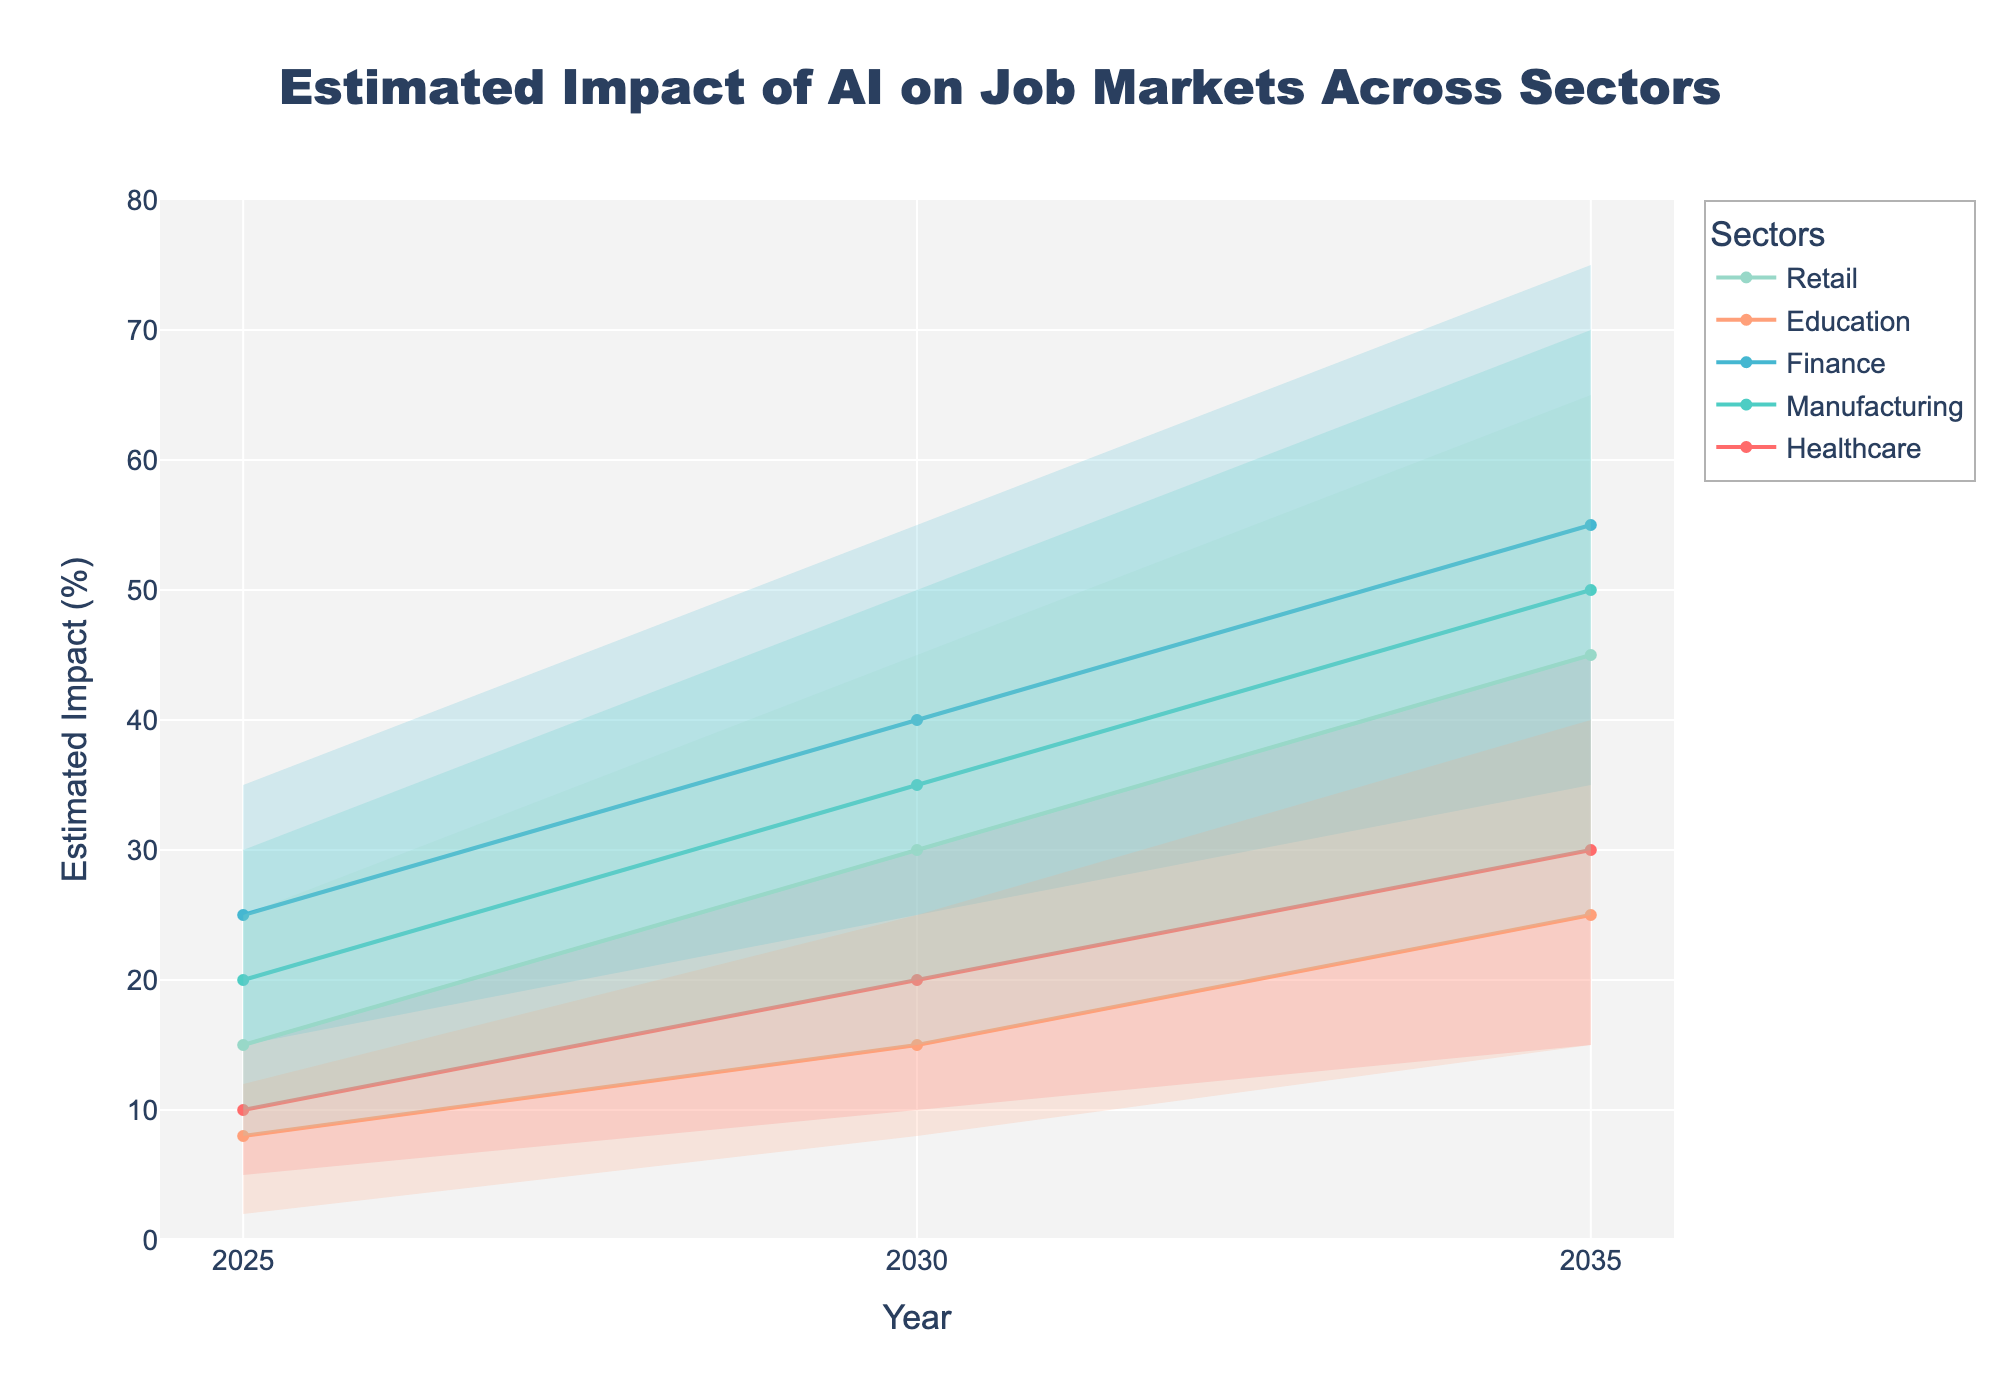What is the title of the chart? The title is generally displayed at the top of the chart in a larger font size.
Answer: Estimated Impact of AI on Job Markets Across Sectors What does the y-axis represent? The y-axis label usually defines what is being measured. Here, it indicates the impact of AI on the job market in percentage terms.
Answer: Estimated Impact (%) How many sectors are being analyzed in the chart? Each sector is represented by distinct lines and colors. By counting them, we can see how many sectors are included.
Answer: 5 Which sector has the highest high estimate in 2035? To answer this, look at the high estimate values plotted for the year 2035. Identify which sector has the highest point.
Answer: Finance What is the estimated range of impact for the healthcare sector in 2025? The range of impact involves the low estimate and high estimate values. Find these values for the healthcare sector in 2025.
Answer: 5% to 15% Between 2025 and 2030, which sector shows the greatest increase in the medium estimate? Compare the medium estimate values between 2025 and 2030 for each sector and find the sector with the largest difference.
Answer: Manufacturing In 2030, which sector has the smallest difference between its high and low estimates? Calculate the difference between high and low estimates for each sector in 2030 and identify the smallest difference.
Answer: Education What is the average high estimate for the retail sector across all years? Take the high estimates for retail for the years 2025, 2030, and 2035, sum them, and then divide by the number of years.
Answer: (25 + 45 + 65) / 3 = 45 Compare the medium estimates of the finance sector in 2025 and 2035. Which year is higher, and by how much? Find the medium estimate values for the finance sector in 2025 and 2035 and subtract the earlier year from the later year to find the difference.
Answer: 55 (in 2035) - 25 (in 2025) = 30 What is the trend of the low estimate for the education sector from 2025 to 2035? Observe the low estimate values for the education sector across the years 2025, 2030, and 2035 to determine the pattern or trend.
Answer: Increasing 